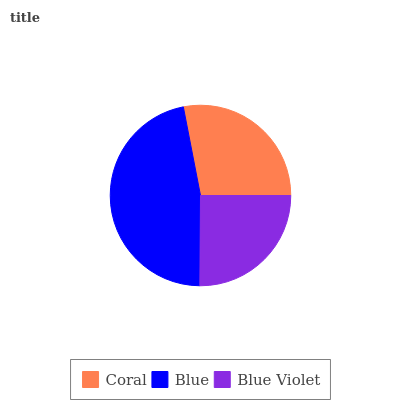Is Blue Violet the minimum?
Answer yes or no. Yes. Is Blue the maximum?
Answer yes or no. Yes. Is Blue the minimum?
Answer yes or no. No. Is Blue Violet the maximum?
Answer yes or no. No. Is Blue greater than Blue Violet?
Answer yes or no. Yes. Is Blue Violet less than Blue?
Answer yes or no. Yes. Is Blue Violet greater than Blue?
Answer yes or no. No. Is Blue less than Blue Violet?
Answer yes or no. No. Is Coral the high median?
Answer yes or no. Yes. Is Coral the low median?
Answer yes or no. Yes. Is Blue the high median?
Answer yes or no. No. Is Blue Violet the low median?
Answer yes or no. No. 